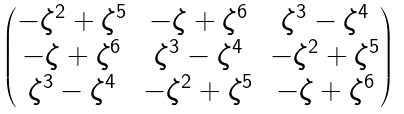Convert formula to latex. <formula><loc_0><loc_0><loc_500><loc_500>\begin{pmatrix} - \zeta ^ { 2 } + \zeta ^ { 5 } & - \zeta + \zeta ^ { 6 } & \zeta ^ { 3 } - \zeta ^ { 4 } \\ - \zeta + \zeta ^ { 6 } & \zeta ^ { 3 } - \zeta ^ { 4 } & - \zeta ^ { 2 } + \zeta ^ { 5 } \\ \zeta ^ { 3 } - \zeta ^ { 4 } & - \zeta ^ { 2 } + \zeta ^ { 5 } & - \zeta + \zeta ^ { 6 } \end{pmatrix}</formula> 